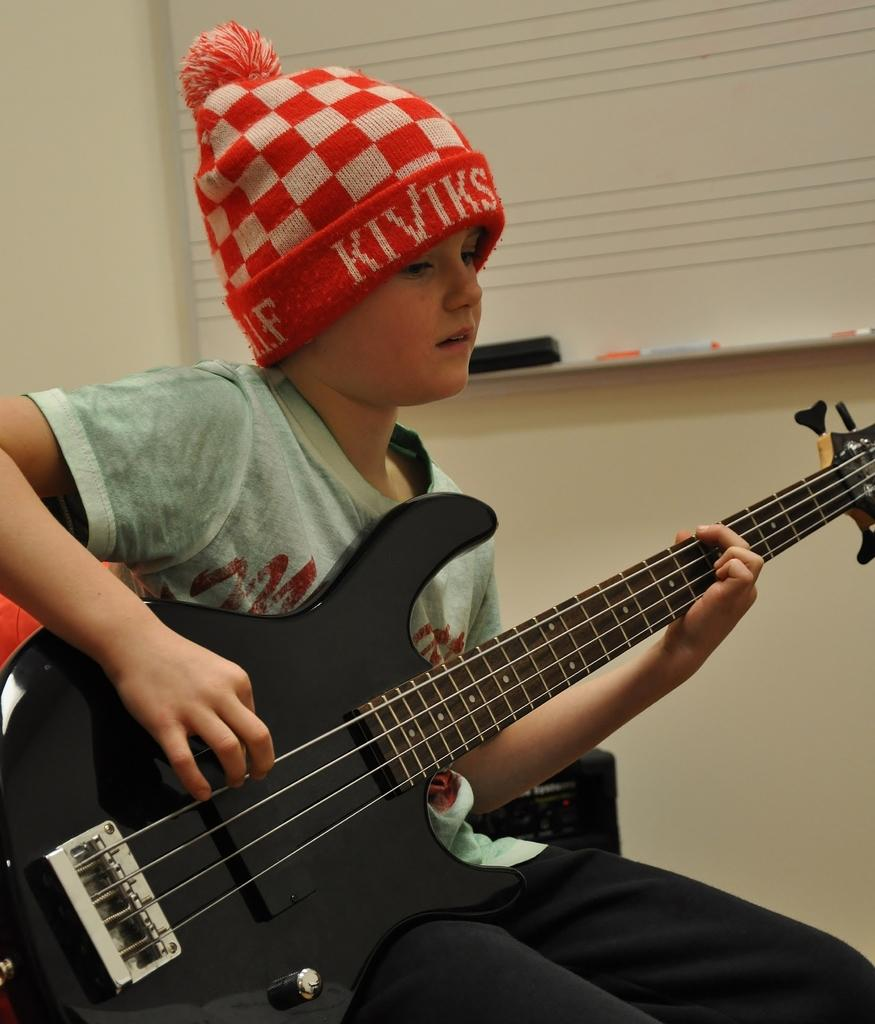What are the boys in the image doing? The boys are sitting on chairs in the image. What are the boys holding while sitting on the chairs? The boys are holding guitars. What can be seen in the background of the image? There is a window and a wall in the background of the image. What type of polish is being applied to the guitar strings in the image? There is no indication in the image that any polish is being applied to the guitar strings. What type of engine can be seen powering the boys' chairs in the image? There are no engines present in the image, and the chairs are not powered. 